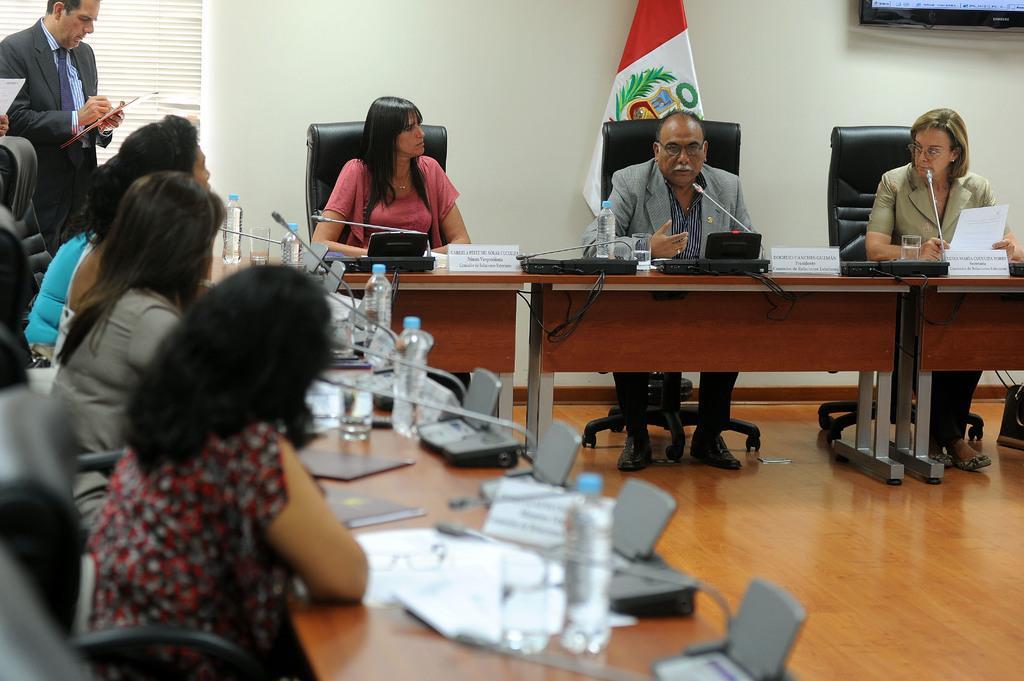In one or two sentences, can you explain what this image depicts? In this picture I can see few people sitting in the chairs and I can few microphones, Water bottles, glasses and papers on the tables and I can see a flag in the back and a television at the top right corner of the picture and I can see a man standing at the top left corner holding a book in his hand. 